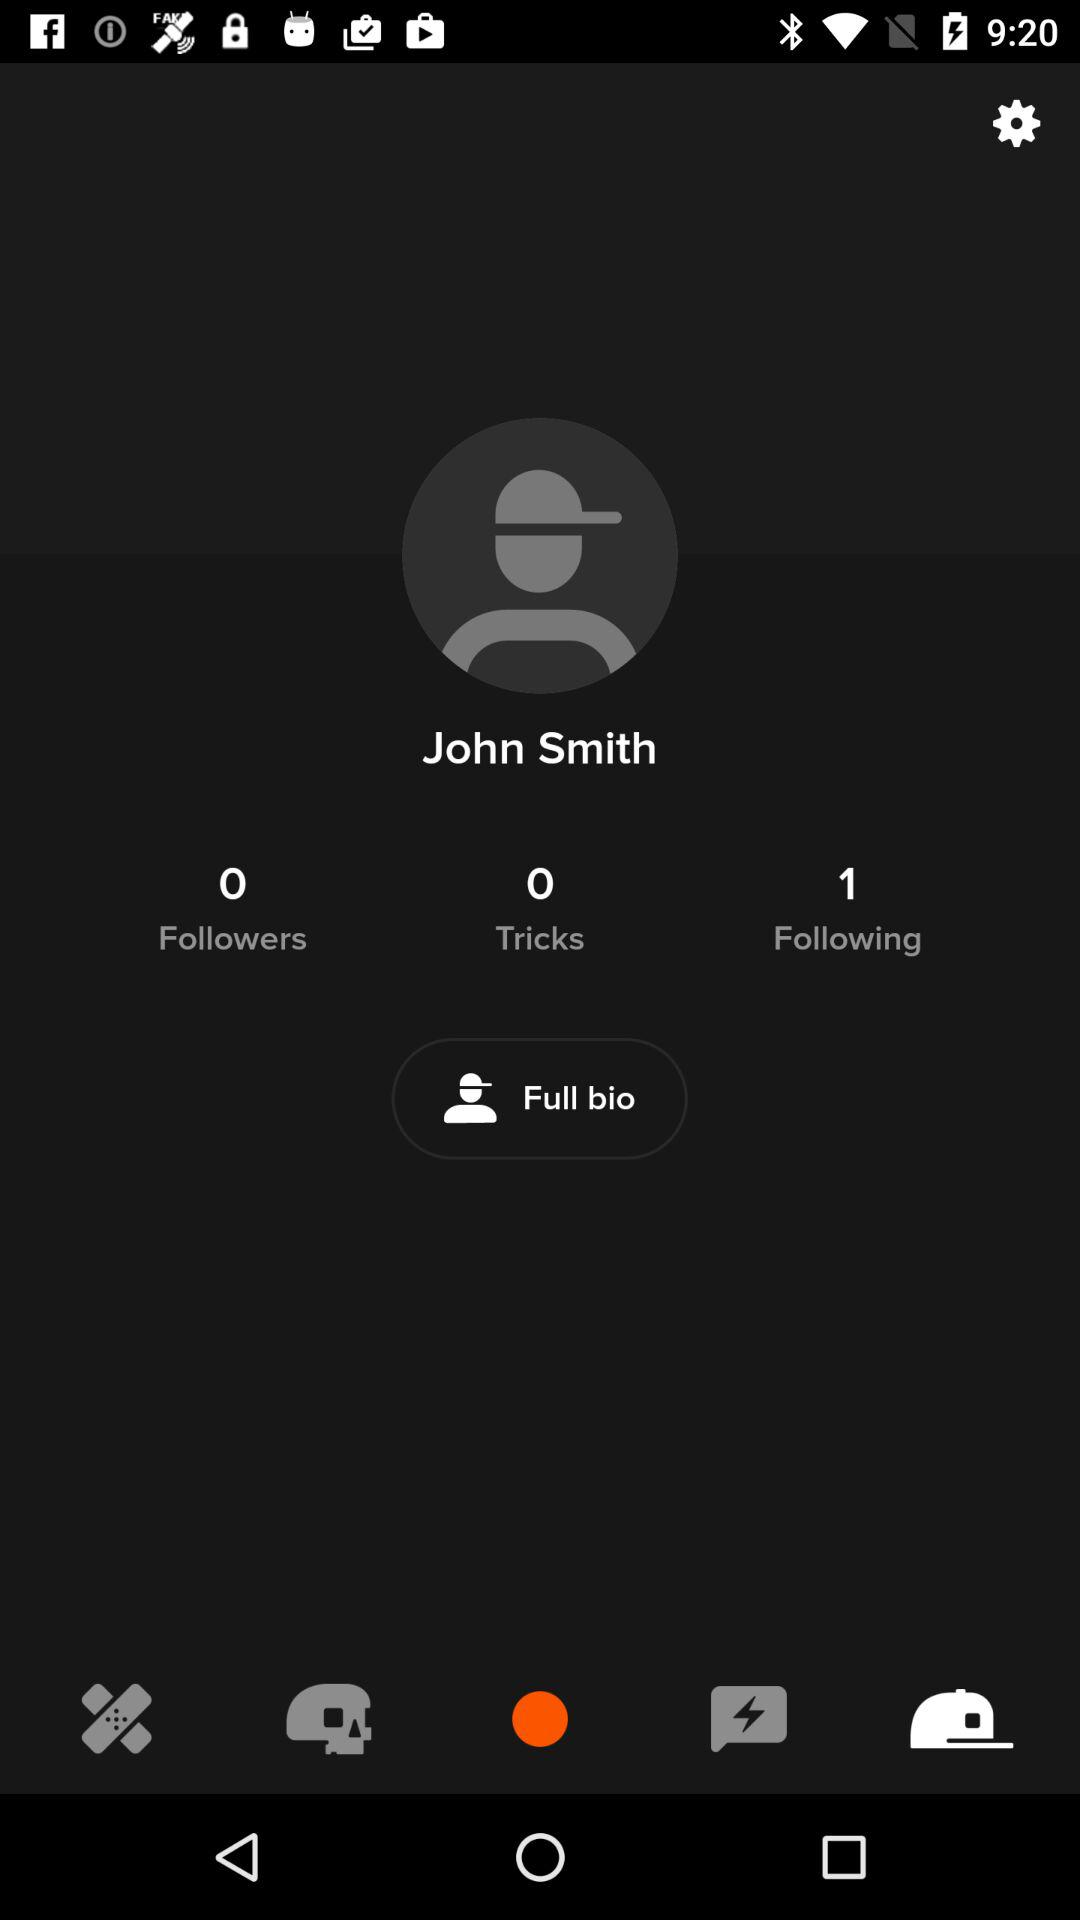What is the user name? The user name is John Smith. 